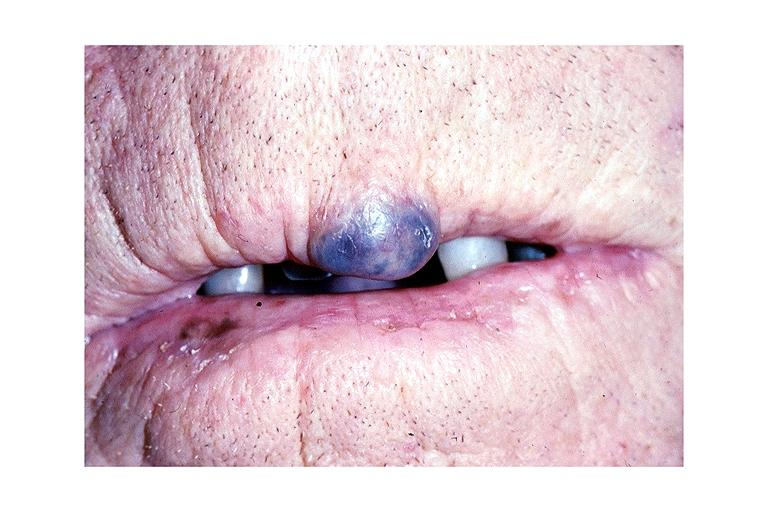s oral present?
Answer the question using a single word or phrase. Yes 